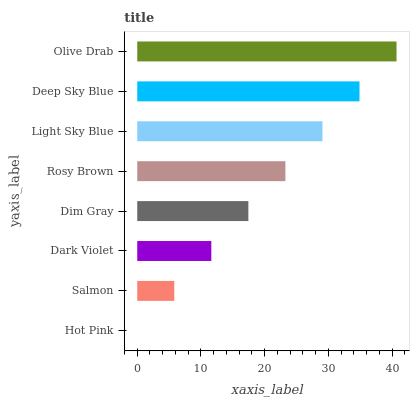Is Hot Pink the minimum?
Answer yes or no. Yes. Is Olive Drab the maximum?
Answer yes or no. Yes. Is Salmon the minimum?
Answer yes or no. No. Is Salmon the maximum?
Answer yes or no. No. Is Salmon greater than Hot Pink?
Answer yes or no. Yes. Is Hot Pink less than Salmon?
Answer yes or no. Yes. Is Hot Pink greater than Salmon?
Answer yes or no. No. Is Salmon less than Hot Pink?
Answer yes or no. No. Is Rosy Brown the high median?
Answer yes or no. Yes. Is Dim Gray the low median?
Answer yes or no. Yes. Is Deep Sky Blue the high median?
Answer yes or no. No. Is Salmon the low median?
Answer yes or no. No. 